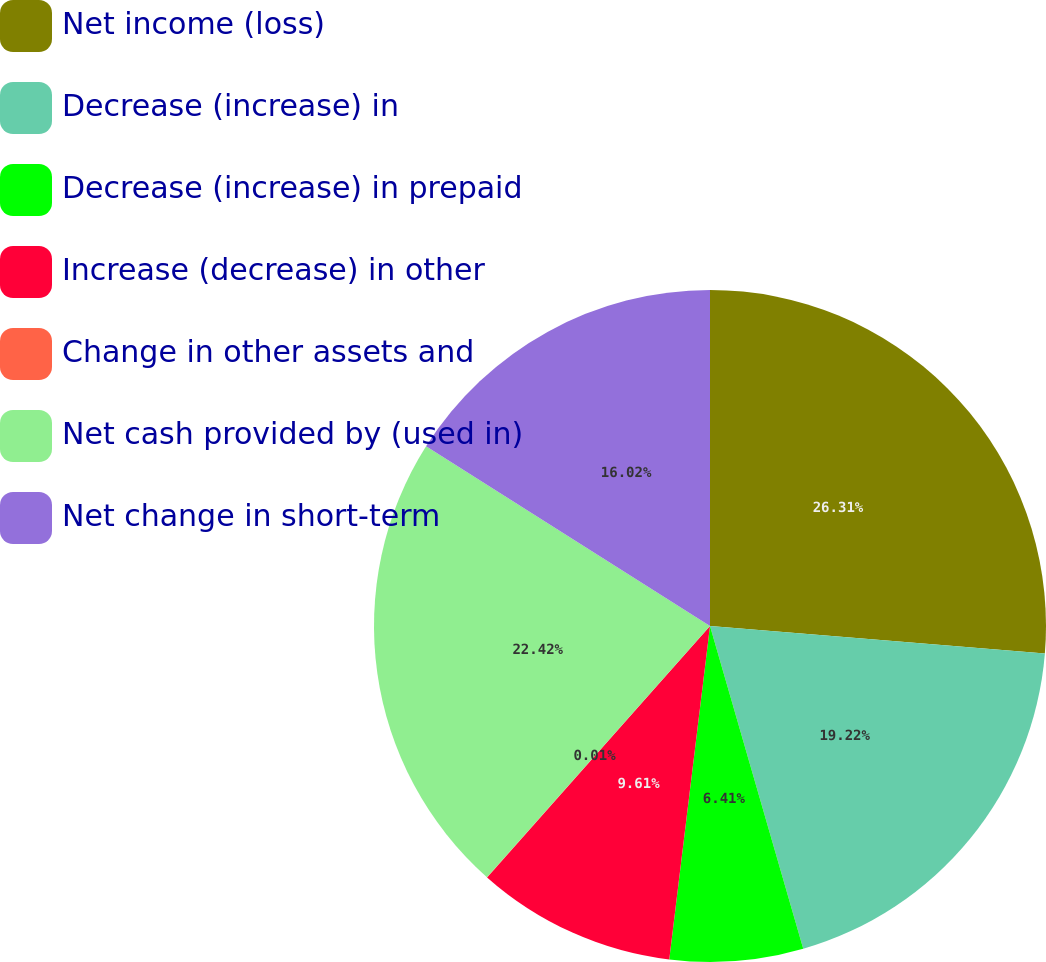Convert chart. <chart><loc_0><loc_0><loc_500><loc_500><pie_chart><fcel>Net income (loss)<fcel>Decrease (increase) in<fcel>Decrease (increase) in prepaid<fcel>Increase (decrease) in other<fcel>Change in other assets and<fcel>Net cash provided by (used in)<fcel>Net change in short-term<nl><fcel>26.3%<fcel>19.22%<fcel>6.41%<fcel>9.61%<fcel>0.01%<fcel>22.42%<fcel>16.02%<nl></chart> 